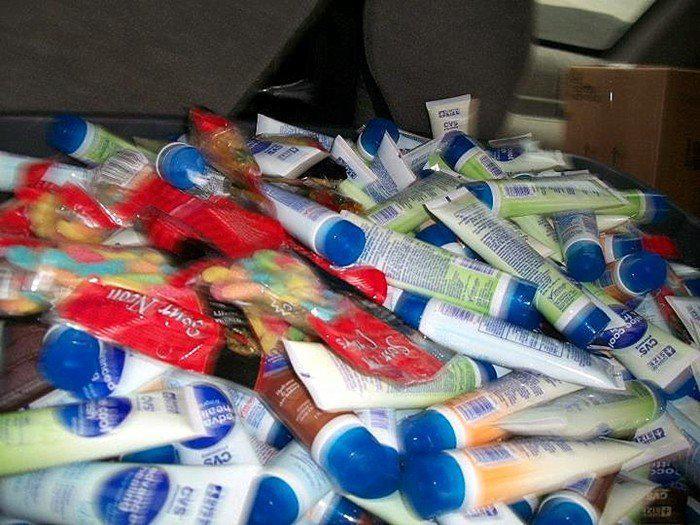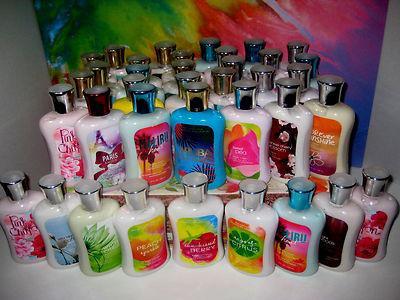The first image is the image on the left, the second image is the image on the right. For the images displayed, is the sentence "The image to the right appears to be all the same brand name lotion, but different scents." factually correct? Answer yes or no. Yes. 